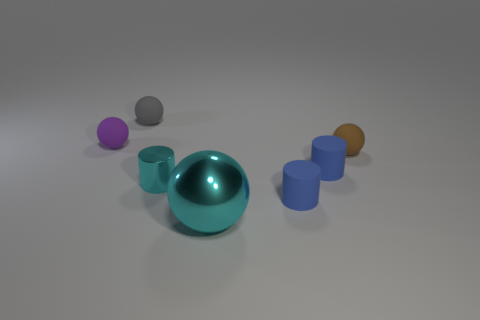Subtract 1 balls. How many balls are left? 3 Add 3 tiny metallic cylinders. How many objects exist? 10 Subtract all brown spheres. How many spheres are left? 3 Subtract all yellow balls. Subtract all blue cylinders. How many balls are left? 4 Subtract all cylinders. How many objects are left? 4 Subtract 0 green spheres. How many objects are left? 7 Subtract all large brown rubber things. Subtract all small objects. How many objects are left? 1 Add 4 metal things. How many metal things are left? 6 Add 3 tiny brown matte cylinders. How many tiny brown matte cylinders exist? 3 